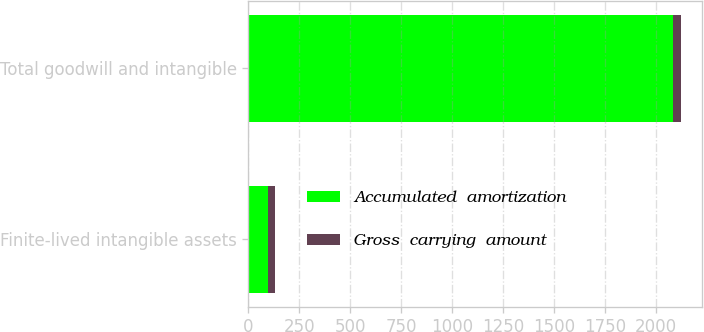Convert chart to OTSL. <chart><loc_0><loc_0><loc_500><loc_500><stacked_bar_chart><ecel><fcel>Finite-lived intangible assets<fcel>Total goodwill and intangible<nl><fcel>Accumulated  amortization<fcel>94.7<fcel>2087.7<nl><fcel>Gross  carrying  amount<fcel>34.7<fcel>34.7<nl></chart> 